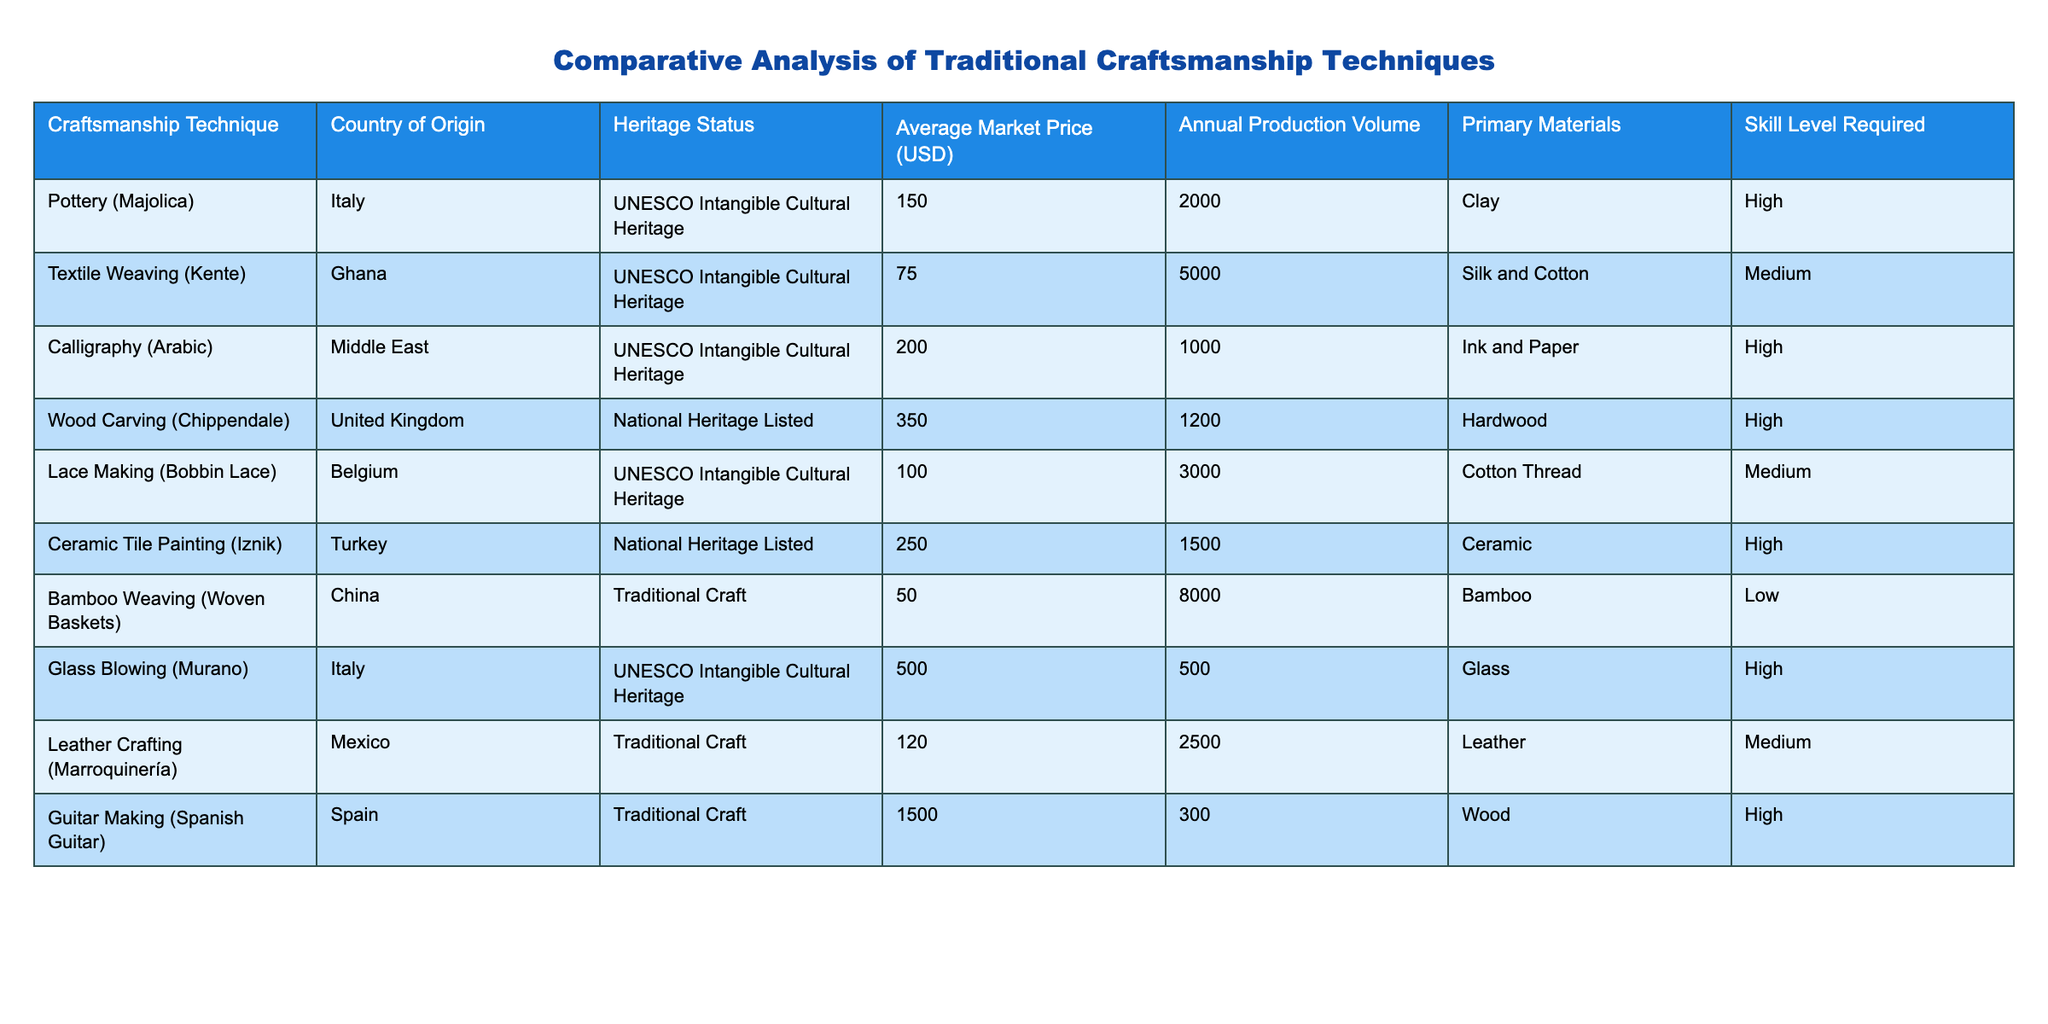What is the average market price of the craftsmanship techniques listed? To find the average market price, sum the average market prices of all craftsmanship techniques (150 + 75 + 200 + 350 + 100 + 250 + 50 + 500 + 120 + 1500) which equals 3875. There are 9 techniques, so divide the total by 9: 3875 / 9 = approximately 430.56.
Answer: 430.56 Which craftsmanship technique has the highest annual production volume? The annual production volumes are 2000, 5000, 1000, 1200, 3000, 1500, 8000, 2500, and 300. The highest among these is 8000 from Bamboo Weaving (Woven Baskets) in China.
Answer: Bamboo Weaving (Woven Baskets) Is Glass Blowing (Murano) classified as UNESCO Intangible Cultural Heritage? The craftsmanship technique Glass Blowing (Murano) is listed in the table with the Heritage Status as UNESCO Intangible Cultural Heritage. Therefore, this statement is true.
Answer: Yes What is the total market value of the craftsmanship techniques from Italy? The techniques from Italy are Pottery (Majolica) with a price of 150 and Glass Blowing (Murano) with a price of 500. Adding these gives 150 + 500 = 650, which represents the total market value of Italian craftsmanship techniques.
Answer: 650 How many craftsmanship techniques require a high skill level, and what is their average market price? The craftsmanship techniques requiring a high skill level are Pottery (Majolica), Calligraphy (Arabic), Wood Carving (Chippendale), Ceramic Tile Painting (Iznik), Glass Blowing (Murano), and Guitar Making (Spanish Guitar). There are 6 techniques. Their prices are 150, 200, 350, 250, 500, and 1500. The total is 2950, and the average is 2950 / 6 = approximately 491.67.
Answer: 6 techniques, average price 491.67 Which country has the lowest average market price for its craftsmanship technique? The technique with the lowest average market price is Bamboo Weaving (Woven Baskets) from China, with a price of 50. Comparing this against all other prices confirms it has the lowest value.
Answer: China Is there any craftsmanship technique in the table that combines both high skill level and is classified as UNESCO Intangible Cultural Heritage? Yes, the techniques that meet both criteria are Pottery (Majolica), Calligraphy (Arabic), and Glass Blowing (Murano).
Answer: Yes 